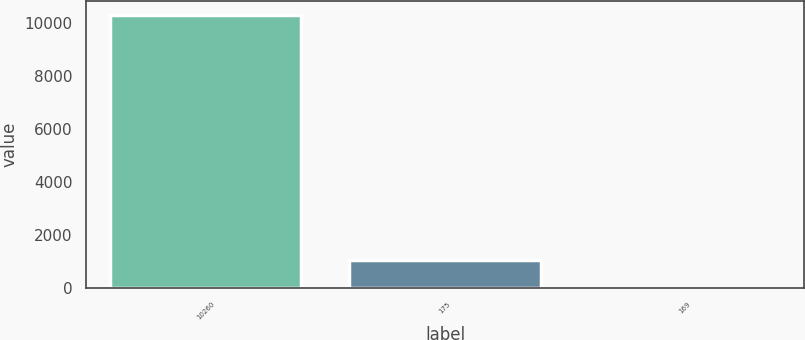<chart> <loc_0><loc_0><loc_500><loc_500><bar_chart><fcel>10260<fcel>175<fcel>169<nl><fcel>10319<fcel>1033.39<fcel>1.65<nl></chart> 